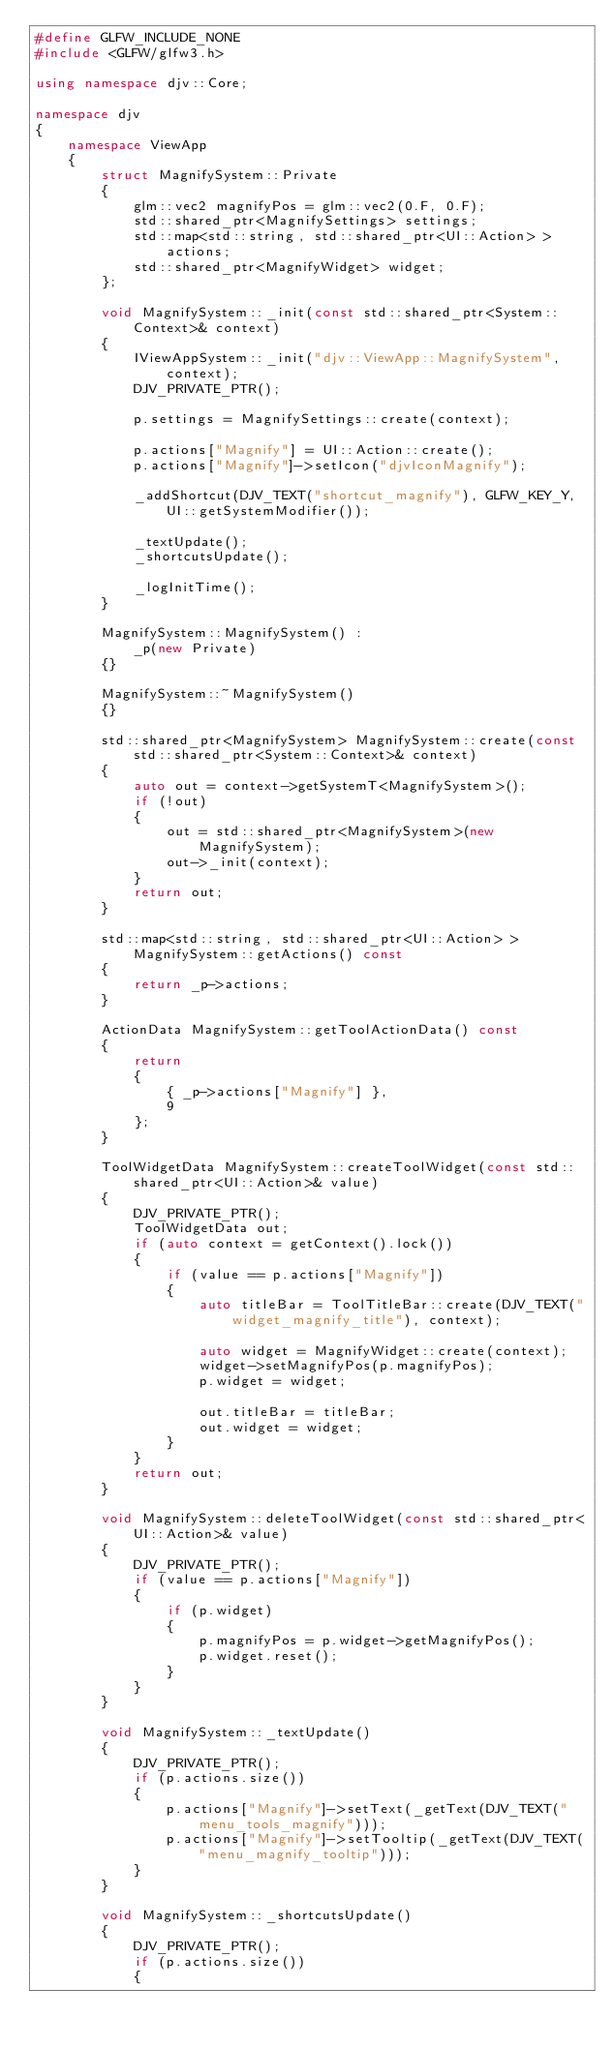Convert code to text. <code><loc_0><loc_0><loc_500><loc_500><_C++_>#define GLFW_INCLUDE_NONE
#include <GLFW/glfw3.h>

using namespace djv::Core;

namespace djv
{
    namespace ViewApp
    {
        struct MagnifySystem::Private
        {
            glm::vec2 magnifyPos = glm::vec2(0.F, 0.F);
            std::shared_ptr<MagnifySettings> settings;
            std::map<std::string, std::shared_ptr<UI::Action> > actions;
            std::shared_ptr<MagnifyWidget> widget;
        };

        void MagnifySystem::_init(const std::shared_ptr<System::Context>& context)
        {
            IViewAppSystem::_init("djv::ViewApp::MagnifySystem", context);
            DJV_PRIVATE_PTR();

            p.settings = MagnifySettings::create(context);

            p.actions["Magnify"] = UI::Action::create();
            p.actions["Magnify"]->setIcon("djvIconMagnify");

            _addShortcut(DJV_TEXT("shortcut_magnify"), GLFW_KEY_Y, UI::getSystemModifier());

            _textUpdate();
            _shortcutsUpdate();

            _logInitTime();
        }

        MagnifySystem::MagnifySystem() :
            _p(new Private)
        {}

        MagnifySystem::~MagnifySystem()
        {}

        std::shared_ptr<MagnifySystem> MagnifySystem::create(const std::shared_ptr<System::Context>& context)
        {
            auto out = context->getSystemT<MagnifySystem>();
            if (!out)
            {
                out = std::shared_ptr<MagnifySystem>(new MagnifySystem);
                out->_init(context);
            }
            return out;
        }

        std::map<std::string, std::shared_ptr<UI::Action> > MagnifySystem::getActions() const
        {
            return _p->actions;
        }

        ActionData MagnifySystem::getToolActionData() const
        {
            return
            {
                { _p->actions["Magnify"] },
                9
            };
        }

        ToolWidgetData MagnifySystem::createToolWidget(const std::shared_ptr<UI::Action>& value)
        {
            DJV_PRIVATE_PTR();
            ToolWidgetData out;
            if (auto context = getContext().lock())
            {
                if (value == p.actions["Magnify"])
                {
                    auto titleBar = ToolTitleBar::create(DJV_TEXT("widget_magnify_title"), context);

                    auto widget = MagnifyWidget::create(context);
                    widget->setMagnifyPos(p.magnifyPos);
                    p.widget = widget;

                    out.titleBar = titleBar;
                    out.widget = widget;
                }
            }
            return out;
        }

        void MagnifySystem::deleteToolWidget(const std::shared_ptr<UI::Action>& value)
        {
            DJV_PRIVATE_PTR();
            if (value == p.actions["Magnify"])
            {
                if (p.widget)
                {
                    p.magnifyPos = p.widget->getMagnifyPos();
                    p.widget.reset();
                }
            }
        }

        void MagnifySystem::_textUpdate()
        {
            DJV_PRIVATE_PTR();
            if (p.actions.size())
            {
                p.actions["Magnify"]->setText(_getText(DJV_TEXT("menu_tools_magnify")));
                p.actions["Magnify"]->setTooltip(_getText(DJV_TEXT("menu_magnify_tooltip")));
            }
        }

        void MagnifySystem::_shortcutsUpdate()
        {
            DJV_PRIVATE_PTR();
            if (p.actions.size())
            {</code> 